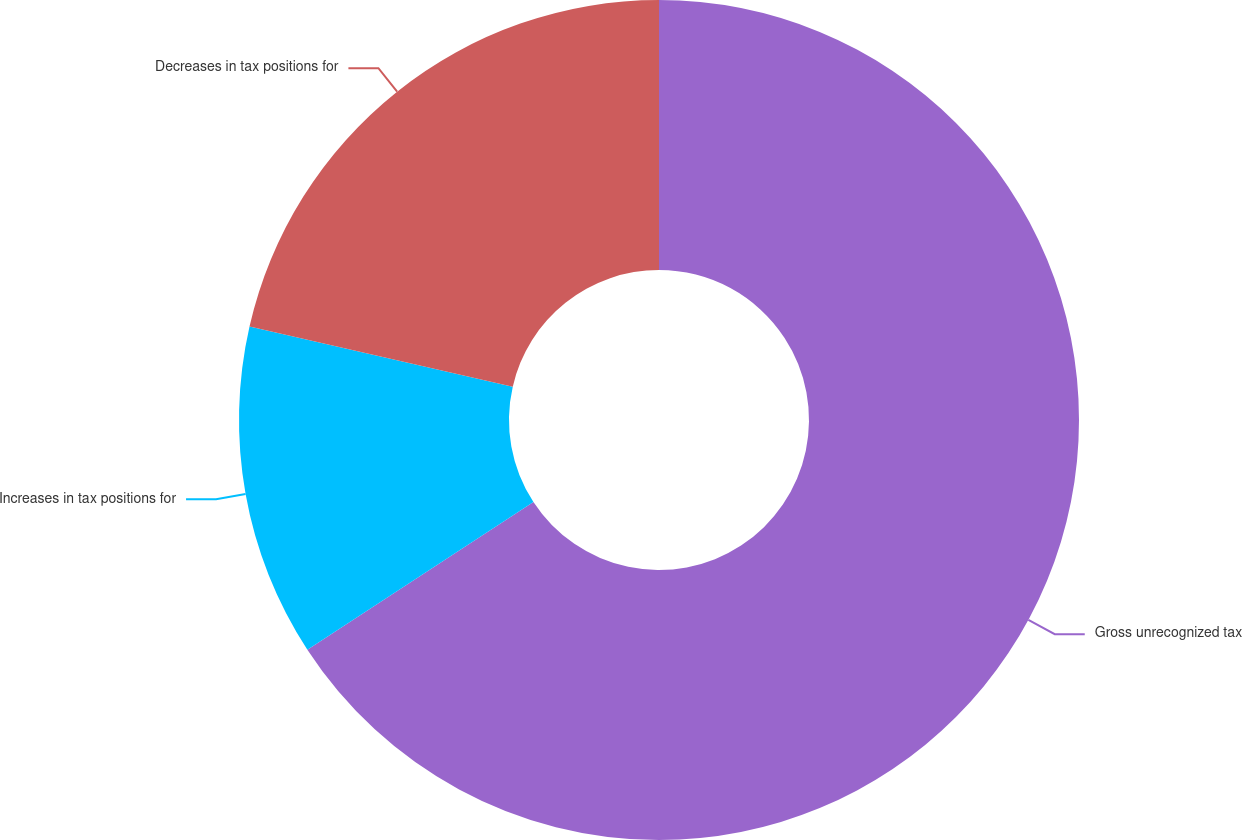Convert chart to OTSL. <chart><loc_0><loc_0><loc_500><loc_500><pie_chart><fcel>Gross unrecognized tax<fcel>Increases in tax positions for<fcel>Decreases in tax positions for<nl><fcel>65.79%<fcel>12.78%<fcel>21.43%<nl></chart> 